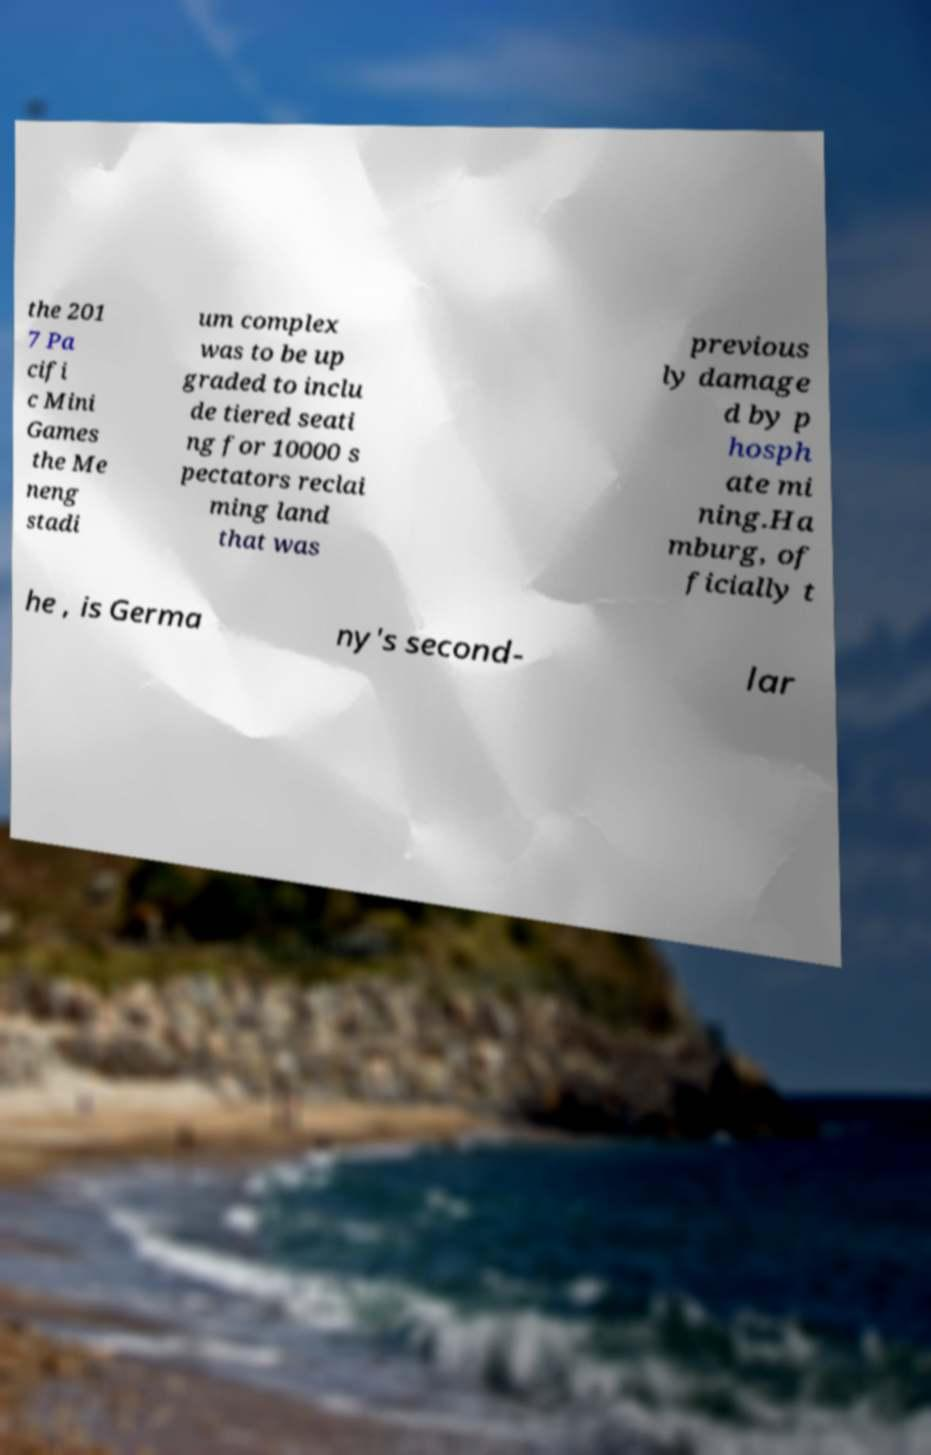For documentation purposes, I need the text within this image transcribed. Could you provide that? the 201 7 Pa cifi c Mini Games the Me neng stadi um complex was to be up graded to inclu de tiered seati ng for 10000 s pectators reclai ming land that was previous ly damage d by p hosph ate mi ning.Ha mburg, of ficially t he , is Germa ny's second- lar 